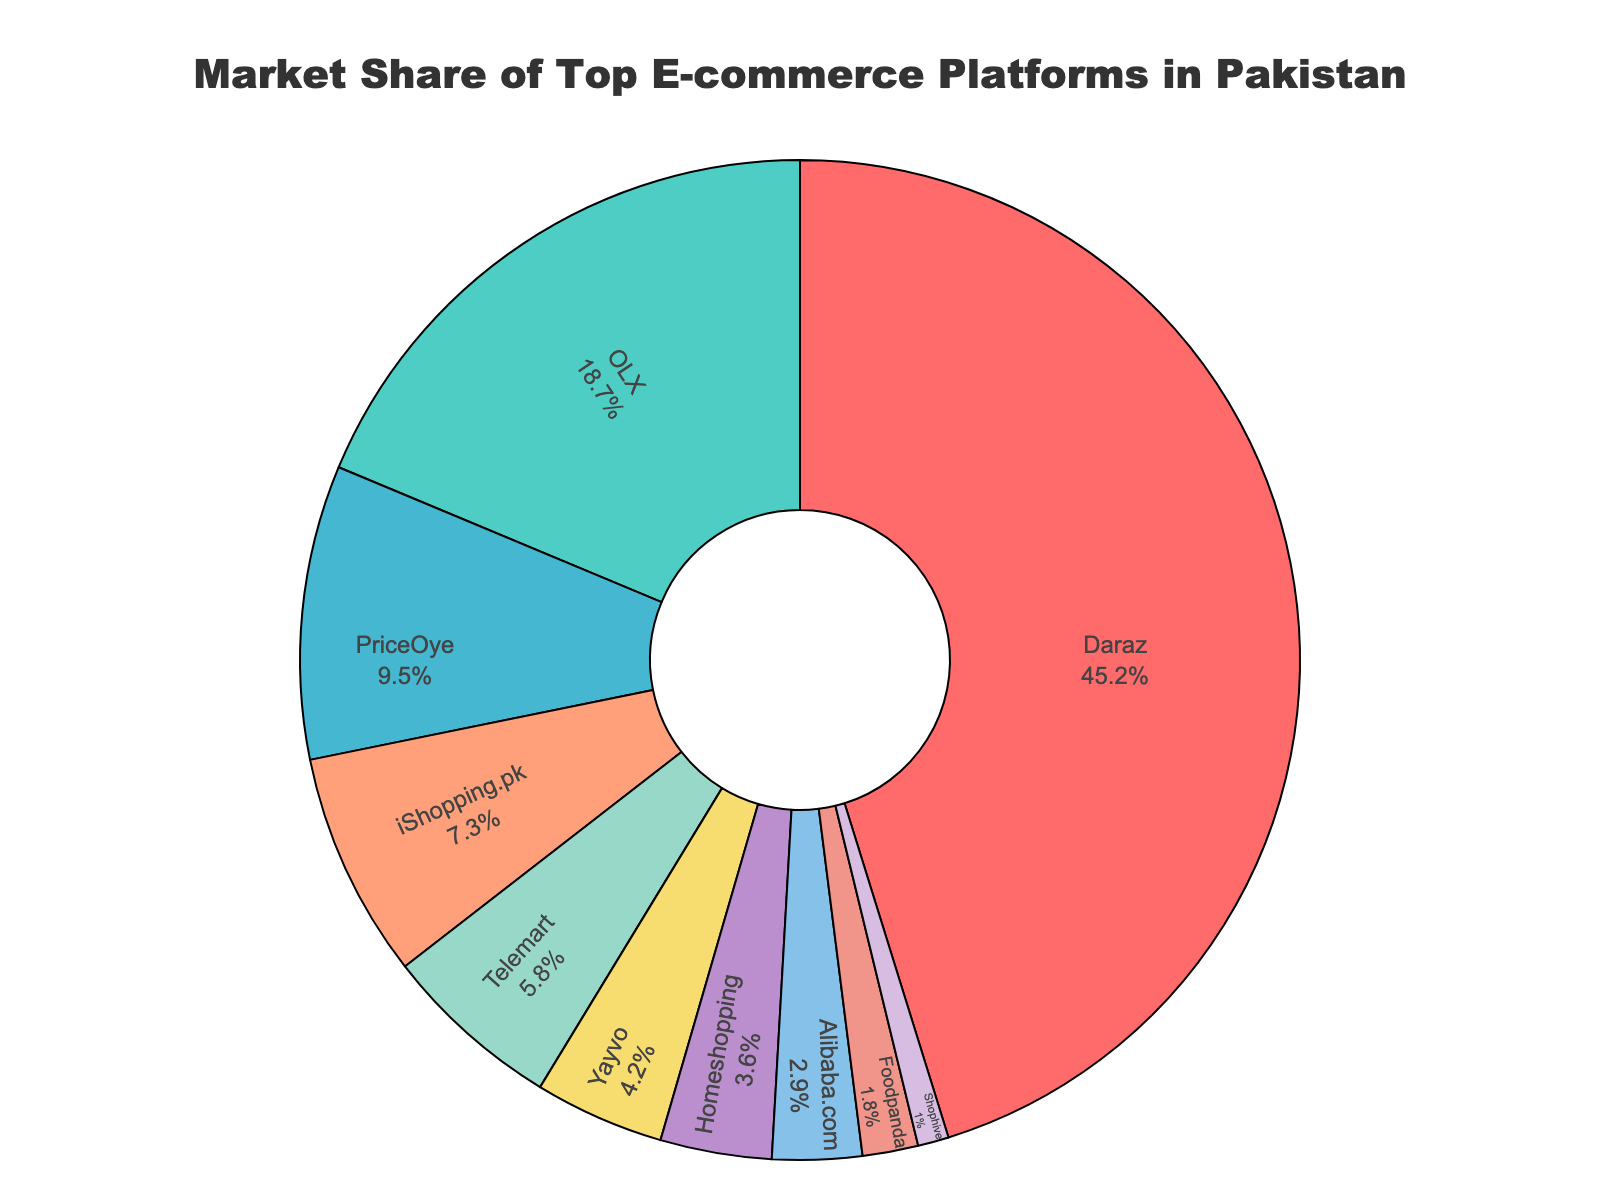Which platform has the highest market share? From the pie chart, the segment representing Daraz is the largest, indicating it has the highest market share.
Answer: Daraz What's the combined market share of OLX and PriceOye? Referring to the pie chart, OLX has a market share of 18.7% and PriceOye has 9.5%. Adding them together results in 18.7 + 9.5 = 28.2%.
Answer: 28.2% Which platforms have a market share of less than 5%? Based on the pie chart, the platforms with a market share of less than 5% are Yayvo (4.2%), Homeshopping (3.6%), Alibaba.com (2.9%), Foodpanda (1.8%), and Shophive (1%).
Answer: Yayvo, Homeshopping, Alibaba.com, Foodpanda, Shophive Is the market share of Daraz greater than the combined market share of iShopping.pk and Telemart? From the figure, Daraz has a market share of 45.2%. Adding iShopping.pk (7.3%) and Telemart (5.8%) gives 7.3 + 5.8 = 13.1%. Hence, Daraz's market share is significantly greater.
Answer: Yes Which platform has the smallest market share? The pie chart indicates that Shophive has the smallest segment, representing the smallest market share at 1%.
Answer: Shophive How much more market share does Daraz have compared to Yayvo? According to the pie chart, Daraz has a market share of 45.2%, and Yayvo has 4.2%. The difference is 45.2 - 4.2 = 41%.
Answer: 41% Are there more platforms with a market share above 10% or below 5%? The platforms above 10% are Daraz (45.2%), OLX (18.7%), and PriceOye (9.5%), totaling 3 platforms. The platforms below 5% are Yayvo (4.2%), Homeshopping (3.6%), Alibaba.com (2.9%), Foodpanda (1.8%), and Shophive (1%), totaling 5 platforms. Therefore, there are more platforms with a market share below 5%.
Answer: Below 5% What is the average market share of the top three platforms? The top three platforms from the chart are Daraz (45.2%), OLX (18.7%), and PriceOye (9.5%). Their average market share is (45.2 + 18.7 + 9.5) / 3 = 24.47%.
Answer: 24.47% Which platform has a market share closest to the combined share of the two smallest platforms? The two smallest platforms are Foodpanda (1.8%) and Shophive (1%), with a combined share of 2.8%. The platform closest to this value is Alibaba.com with a market share of 2.9%.
Answer: Alibaba.com 